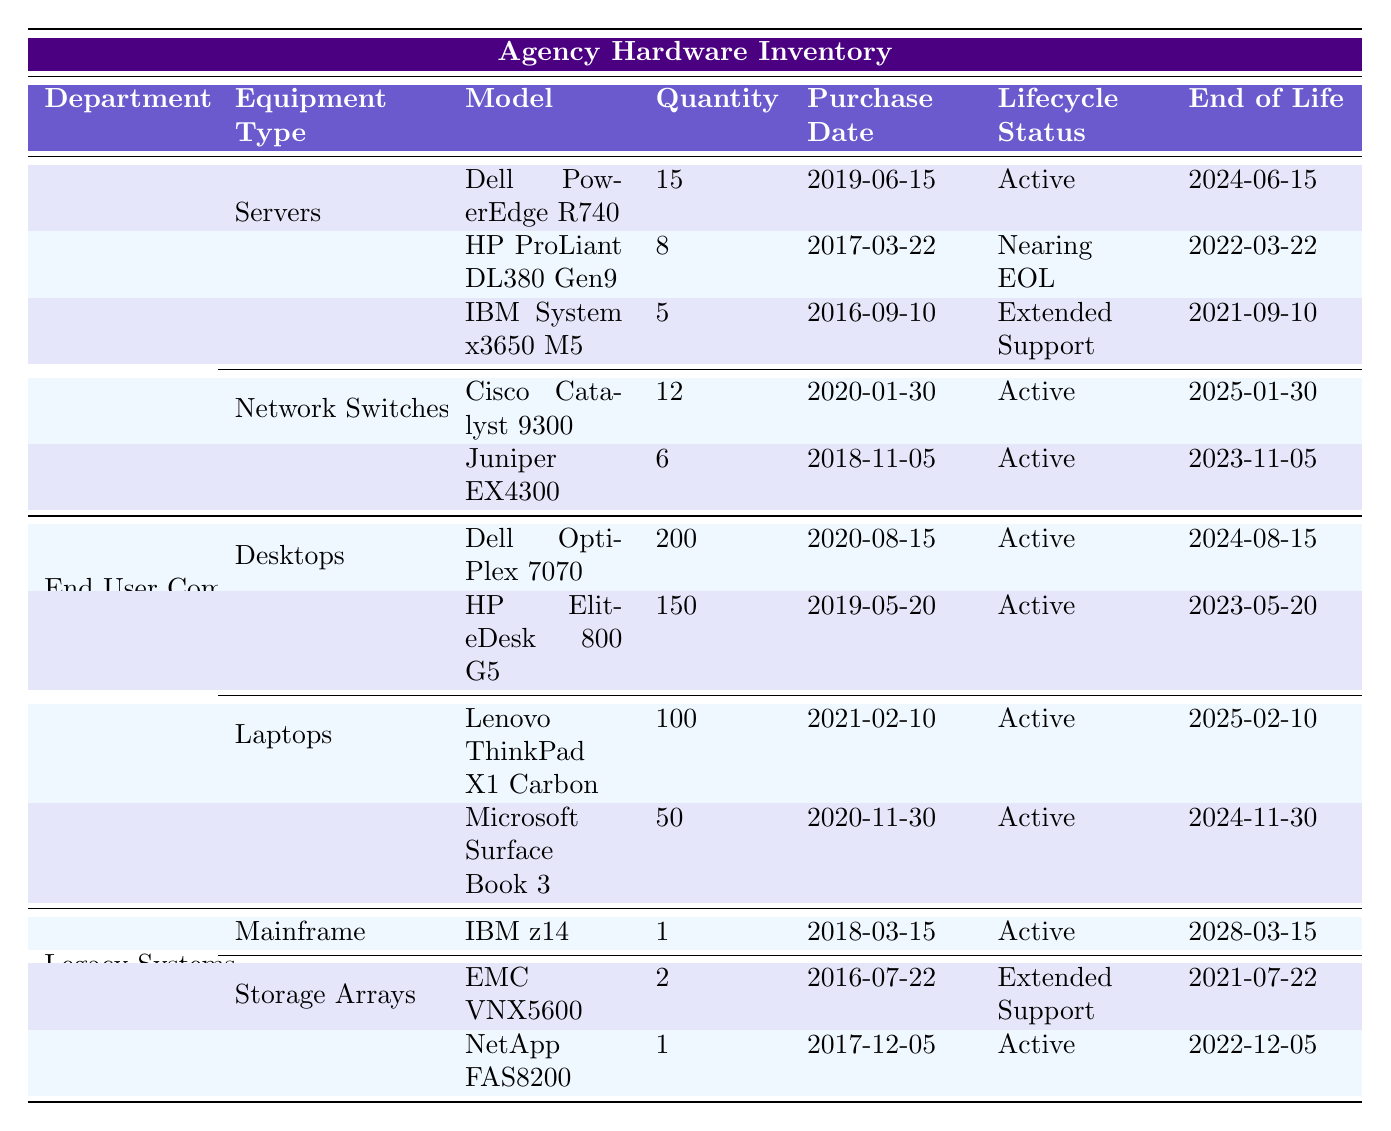What is the total quantity of servers in the IT Infrastructure department? In the IT Infrastructure department, there are three types of servers: Dell PowerEdge R740 (15 units), HP ProLiant DL380 Gen9 (8 units), and IBM System x3650 M5 (5 units). The total is calculated by adding these quantities: 15 + 8 + 5 = 28.
Answer: 28 Which model of desktops has the highest quantity? In the End User Computing department under Desktops, there are two models: Dell OptiPlex 7070 (200 units) and HP EliteDesk 800 G5 (150 units). The model with the highest quantity is the Dell OptiPlex 7070 with 200 units.
Answer: Dell OptiPlex 7070 Is the HP ProLiant DL380 Gen9 still under the lifecycle support? The HP ProLiant DL380 Gen9 has a lifecycle status of "Nearing EOL," indicating it is approaching end-of-life status and is therefore no longer fully supported.
Answer: No What percentage of the total laptops does the Microsoft Surface Book 3 represent? There are 100 Lenovo ThinkPad X1 Carbon and 50 Microsoft Surface Book 3, totaling 150 laptops. To find the percentage that the Microsoft Surface Book 3 represents: (50 / 150) * 100 = 33.33%.
Answer: 33.33% How many pieces of equipment in the Legacy Systems department are in Extended Support? In the Legacy Systems department, the EMC VNX5600 is in Extended Support, while the NetApp FAS8200 is Active, and the IBM z14 is also Active. Thus, only 1 piece of equipment is in Extended Support.
Answer: 1 Which department has the least quantity of equipment according to the table? The Legacy Systems department has a total of 4 items (1 Mainframe and 2 Storage Arrays), while IT Infrastructure has 8 and End User Computing has 4 as well (2 Desktops and 2 Laptops). Since both Legacy Systems and End User Computing have 4, they tie for the least quantity.
Answer: Legacy Systems and End User Computing What is the average lifespan remaining for all active servers? The active servers and their end-of-life dates are: Dell PowerEdge R740 (2024-06-15), Cisco Catalyst 9300 (2025-01-30), and Juniper EX4300 (2023-11-05). The remaining lifespans are: Dell (1.5 years), Cisco (2.5 years), and Juniper (0.5 years). The average lifespan is (1.5 + 2.5 + 0.5) / 3 = 1.67 years.
Answer: 1.67 years How many departments have equipment with a lifecycle status of "Active"? All three departments (IT Infrastructure, End User Computing, and Legacy Systems) have equipment with the lifecycle status of "Active." Each department has at least one active item listed.
Answer: 3 Is there any equipment with an End of Life date in 2023? The Juniper EX4300 in IT Infrastructure has an End of Life set for 2023-11-05, and the HP EliteDesk 800 G5 in End User Computing has an End of Life set for 2023-05-20, confirming the existence of such equipment.
Answer: Yes What is the total number of desktops and laptops across the End User Computing department? The End User Computing department has 200 Dell OptiPlex 7070 and 150 HP EliteDesk 800 G5 (Desktops), adding to 350 total desktops, plus 100 Lenovo ThinkPad X1 Carbon and 50 Microsoft Surface Book 3 (Laptops), which adds up to 150 total laptops. Therefore, the total is: 350 + 150 = 500.
Answer: 500 